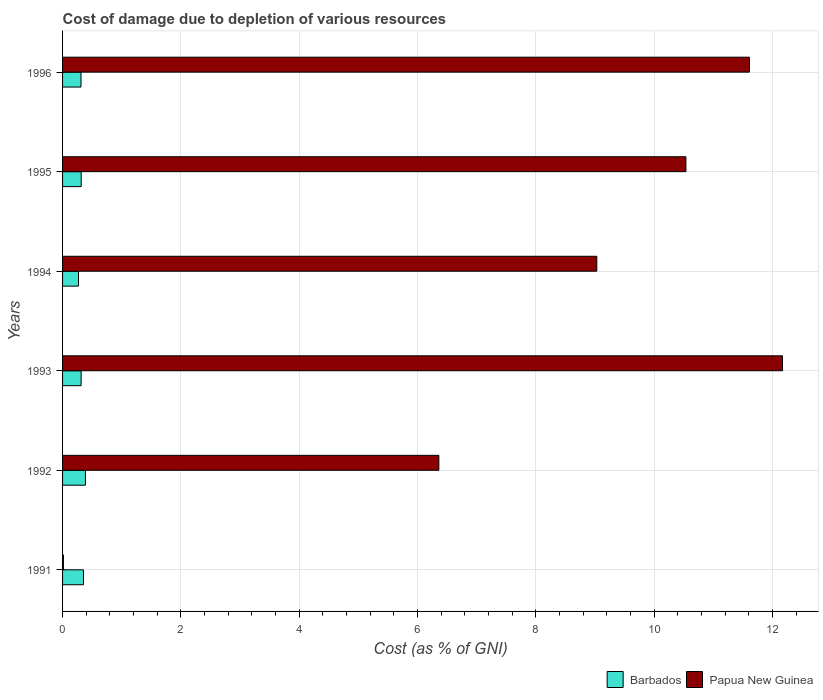How many different coloured bars are there?
Ensure brevity in your answer.  2. How many bars are there on the 3rd tick from the bottom?
Your response must be concise. 2. What is the label of the 1st group of bars from the top?
Provide a short and direct response. 1996. What is the cost of damage caused due to the depletion of various resources in Barbados in 1995?
Offer a very short reply. 0.32. Across all years, what is the maximum cost of damage caused due to the depletion of various resources in Papua New Guinea?
Ensure brevity in your answer.  12.17. Across all years, what is the minimum cost of damage caused due to the depletion of various resources in Barbados?
Your response must be concise. 0.27. In which year was the cost of damage caused due to the depletion of various resources in Papua New Guinea minimum?
Your response must be concise. 1991. What is the total cost of damage caused due to the depletion of various resources in Papua New Guinea in the graph?
Give a very brief answer. 49.71. What is the difference between the cost of damage caused due to the depletion of various resources in Barbados in 1993 and that in 1995?
Offer a very short reply. -0. What is the difference between the cost of damage caused due to the depletion of various resources in Barbados in 1994 and the cost of damage caused due to the depletion of various resources in Papua New Guinea in 1996?
Keep it short and to the point. -11.34. What is the average cost of damage caused due to the depletion of various resources in Barbados per year?
Offer a terse response. 0.32. In the year 1995, what is the difference between the cost of damage caused due to the depletion of various resources in Papua New Guinea and cost of damage caused due to the depletion of various resources in Barbados?
Offer a very short reply. 10.22. In how many years, is the cost of damage caused due to the depletion of various resources in Papua New Guinea greater than 0.4 %?
Your response must be concise. 5. What is the ratio of the cost of damage caused due to the depletion of various resources in Papua New Guinea in 1991 to that in 1994?
Your answer should be compact. 0. What is the difference between the highest and the second highest cost of damage caused due to the depletion of various resources in Barbados?
Your answer should be very brief. 0.03. What is the difference between the highest and the lowest cost of damage caused due to the depletion of various resources in Barbados?
Give a very brief answer. 0.12. What does the 1st bar from the top in 1996 represents?
Offer a terse response. Papua New Guinea. What does the 2nd bar from the bottom in 1995 represents?
Your answer should be very brief. Papua New Guinea. How many bars are there?
Offer a terse response. 12. How many years are there in the graph?
Your answer should be very brief. 6. Does the graph contain grids?
Give a very brief answer. Yes. What is the title of the graph?
Provide a short and direct response. Cost of damage due to depletion of various resources. Does "Peru" appear as one of the legend labels in the graph?
Provide a short and direct response. No. What is the label or title of the X-axis?
Your answer should be very brief. Cost (as % of GNI). What is the label or title of the Y-axis?
Keep it short and to the point. Years. What is the Cost (as % of GNI) in Barbados in 1991?
Offer a very short reply. 0.35. What is the Cost (as % of GNI) in Papua New Guinea in 1991?
Provide a short and direct response. 0.01. What is the Cost (as % of GNI) in Barbados in 1992?
Make the answer very short. 0.39. What is the Cost (as % of GNI) in Papua New Guinea in 1992?
Ensure brevity in your answer.  6.36. What is the Cost (as % of GNI) of Barbados in 1993?
Offer a very short reply. 0.31. What is the Cost (as % of GNI) of Papua New Guinea in 1993?
Your answer should be very brief. 12.17. What is the Cost (as % of GNI) in Barbados in 1994?
Make the answer very short. 0.27. What is the Cost (as % of GNI) of Papua New Guinea in 1994?
Your answer should be very brief. 9.03. What is the Cost (as % of GNI) in Barbados in 1995?
Ensure brevity in your answer.  0.32. What is the Cost (as % of GNI) in Papua New Guinea in 1995?
Give a very brief answer. 10.54. What is the Cost (as % of GNI) in Barbados in 1996?
Offer a terse response. 0.31. What is the Cost (as % of GNI) in Papua New Guinea in 1996?
Offer a very short reply. 11.61. Across all years, what is the maximum Cost (as % of GNI) of Barbados?
Make the answer very short. 0.39. Across all years, what is the maximum Cost (as % of GNI) of Papua New Guinea?
Your response must be concise. 12.17. Across all years, what is the minimum Cost (as % of GNI) of Barbados?
Keep it short and to the point. 0.27. Across all years, what is the minimum Cost (as % of GNI) of Papua New Guinea?
Provide a short and direct response. 0.01. What is the total Cost (as % of GNI) of Barbados in the graph?
Provide a succinct answer. 1.95. What is the total Cost (as % of GNI) in Papua New Guinea in the graph?
Keep it short and to the point. 49.71. What is the difference between the Cost (as % of GNI) in Barbados in 1991 and that in 1992?
Provide a succinct answer. -0.03. What is the difference between the Cost (as % of GNI) of Papua New Guinea in 1991 and that in 1992?
Offer a terse response. -6.34. What is the difference between the Cost (as % of GNI) of Barbados in 1991 and that in 1993?
Give a very brief answer. 0.04. What is the difference between the Cost (as % of GNI) in Papua New Guinea in 1991 and that in 1993?
Your answer should be compact. -12.15. What is the difference between the Cost (as % of GNI) of Barbados in 1991 and that in 1994?
Offer a very short reply. 0.08. What is the difference between the Cost (as % of GNI) of Papua New Guinea in 1991 and that in 1994?
Your answer should be compact. -9.01. What is the difference between the Cost (as % of GNI) of Barbados in 1991 and that in 1995?
Provide a succinct answer. 0.04. What is the difference between the Cost (as % of GNI) of Papua New Guinea in 1991 and that in 1995?
Make the answer very short. -10.52. What is the difference between the Cost (as % of GNI) in Barbados in 1991 and that in 1996?
Provide a short and direct response. 0.04. What is the difference between the Cost (as % of GNI) in Papua New Guinea in 1991 and that in 1996?
Offer a very short reply. -11.59. What is the difference between the Cost (as % of GNI) in Barbados in 1992 and that in 1993?
Make the answer very short. 0.07. What is the difference between the Cost (as % of GNI) of Papua New Guinea in 1992 and that in 1993?
Provide a short and direct response. -5.81. What is the difference between the Cost (as % of GNI) in Barbados in 1992 and that in 1994?
Make the answer very short. 0.12. What is the difference between the Cost (as % of GNI) of Papua New Guinea in 1992 and that in 1994?
Your response must be concise. -2.67. What is the difference between the Cost (as % of GNI) of Barbados in 1992 and that in 1995?
Provide a succinct answer. 0.07. What is the difference between the Cost (as % of GNI) of Papua New Guinea in 1992 and that in 1995?
Offer a very short reply. -4.18. What is the difference between the Cost (as % of GNI) in Barbados in 1992 and that in 1996?
Your response must be concise. 0.07. What is the difference between the Cost (as % of GNI) of Papua New Guinea in 1992 and that in 1996?
Your answer should be very brief. -5.25. What is the difference between the Cost (as % of GNI) of Barbados in 1993 and that in 1994?
Your answer should be very brief. 0.04. What is the difference between the Cost (as % of GNI) in Papua New Guinea in 1993 and that in 1994?
Provide a short and direct response. 3.14. What is the difference between the Cost (as % of GNI) of Barbados in 1993 and that in 1995?
Your answer should be very brief. -0. What is the difference between the Cost (as % of GNI) in Papua New Guinea in 1993 and that in 1995?
Your answer should be compact. 1.63. What is the difference between the Cost (as % of GNI) of Barbados in 1993 and that in 1996?
Your response must be concise. 0. What is the difference between the Cost (as % of GNI) of Papua New Guinea in 1993 and that in 1996?
Keep it short and to the point. 0.56. What is the difference between the Cost (as % of GNI) of Barbados in 1994 and that in 1995?
Your answer should be very brief. -0.05. What is the difference between the Cost (as % of GNI) of Papua New Guinea in 1994 and that in 1995?
Offer a terse response. -1.51. What is the difference between the Cost (as % of GNI) of Barbados in 1994 and that in 1996?
Make the answer very short. -0.04. What is the difference between the Cost (as % of GNI) in Papua New Guinea in 1994 and that in 1996?
Provide a succinct answer. -2.58. What is the difference between the Cost (as % of GNI) in Barbados in 1995 and that in 1996?
Offer a very short reply. 0. What is the difference between the Cost (as % of GNI) in Papua New Guinea in 1995 and that in 1996?
Your response must be concise. -1.07. What is the difference between the Cost (as % of GNI) of Barbados in 1991 and the Cost (as % of GNI) of Papua New Guinea in 1992?
Make the answer very short. -6.01. What is the difference between the Cost (as % of GNI) in Barbados in 1991 and the Cost (as % of GNI) in Papua New Guinea in 1993?
Provide a short and direct response. -11.81. What is the difference between the Cost (as % of GNI) in Barbados in 1991 and the Cost (as % of GNI) in Papua New Guinea in 1994?
Your answer should be compact. -8.68. What is the difference between the Cost (as % of GNI) in Barbados in 1991 and the Cost (as % of GNI) in Papua New Guinea in 1995?
Make the answer very short. -10.18. What is the difference between the Cost (as % of GNI) of Barbados in 1991 and the Cost (as % of GNI) of Papua New Guinea in 1996?
Keep it short and to the point. -11.26. What is the difference between the Cost (as % of GNI) in Barbados in 1992 and the Cost (as % of GNI) in Papua New Guinea in 1993?
Provide a succinct answer. -11.78. What is the difference between the Cost (as % of GNI) of Barbados in 1992 and the Cost (as % of GNI) of Papua New Guinea in 1994?
Give a very brief answer. -8.64. What is the difference between the Cost (as % of GNI) in Barbados in 1992 and the Cost (as % of GNI) in Papua New Guinea in 1995?
Give a very brief answer. -10.15. What is the difference between the Cost (as % of GNI) of Barbados in 1992 and the Cost (as % of GNI) of Papua New Guinea in 1996?
Your answer should be very brief. -11.22. What is the difference between the Cost (as % of GNI) of Barbados in 1993 and the Cost (as % of GNI) of Papua New Guinea in 1994?
Offer a very short reply. -8.72. What is the difference between the Cost (as % of GNI) in Barbados in 1993 and the Cost (as % of GNI) in Papua New Guinea in 1995?
Provide a short and direct response. -10.22. What is the difference between the Cost (as % of GNI) of Barbados in 1993 and the Cost (as % of GNI) of Papua New Guinea in 1996?
Provide a short and direct response. -11.29. What is the difference between the Cost (as % of GNI) in Barbados in 1994 and the Cost (as % of GNI) in Papua New Guinea in 1995?
Offer a terse response. -10.27. What is the difference between the Cost (as % of GNI) in Barbados in 1994 and the Cost (as % of GNI) in Papua New Guinea in 1996?
Your response must be concise. -11.34. What is the difference between the Cost (as % of GNI) of Barbados in 1995 and the Cost (as % of GNI) of Papua New Guinea in 1996?
Give a very brief answer. -11.29. What is the average Cost (as % of GNI) of Barbados per year?
Offer a terse response. 0.32. What is the average Cost (as % of GNI) of Papua New Guinea per year?
Your response must be concise. 8.29. In the year 1991, what is the difference between the Cost (as % of GNI) of Barbados and Cost (as % of GNI) of Papua New Guinea?
Offer a terse response. 0.34. In the year 1992, what is the difference between the Cost (as % of GNI) of Barbados and Cost (as % of GNI) of Papua New Guinea?
Provide a short and direct response. -5.97. In the year 1993, what is the difference between the Cost (as % of GNI) of Barbados and Cost (as % of GNI) of Papua New Guinea?
Make the answer very short. -11.85. In the year 1994, what is the difference between the Cost (as % of GNI) in Barbados and Cost (as % of GNI) in Papua New Guinea?
Provide a short and direct response. -8.76. In the year 1995, what is the difference between the Cost (as % of GNI) of Barbados and Cost (as % of GNI) of Papua New Guinea?
Your answer should be compact. -10.22. In the year 1996, what is the difference between the Cost (as % of GNI) of Barbados and Cost (as % of GNI) of Papua New Guinea?
Give a very brief answer. -11.3. What is the ratio of the Cost (as % of GNI) in Barbados in 1991 to that in 1992?
Your answer should be very brief. 0.91. What is the ratio of the Cost (as % of GNI) of Papua New Guinea in 1991 to that in 1992?
Ensure brevity in your answer.  0. What is the ratio of the Cost (as % of GNI) of Barbados in 1991 to that in 1993?
Your answer should be compact. 1.12. What is the ratio of the Cost (as % of GNI) in Papua New Guinea in 1991 to that in 1993?
Keep it short and to the point. 0. What is the ratio of the Cost (as % of GNI) of Barbados in 1991 to that in 1994?
Ensure brevity in your answer.  1.31. What is the ratio of the Cost (as % of GNI) of Papua New Guinea in 1991 to that in 1994?
Offer a terse response. 0. What is the ratio of the Cost (as % of GNI) in Barbados in 1991 to that in 1995?
Offer a very short reply. 1.12. What is the ratio of the Cost (as % of GNI) of Papua New Guinea in 1991 to that in 1995?
Provide a succinct answer. 0. What is the ratio of the Cost (as % of GNI) of Barbados in 1991 to that in 1996?
Offer a very short reply. 1.13. What is the ratio of the Cost (as % of GNI) in Papua New Guinea in 1991 to that in 1996?
Your response must be concise. 0. What is the ratio of the Cost (as % of GNI) in Barbados in 1992 to that in 1993?
Your answer should be compact. 1.23. What is the ratio of the Cost (as % of GNI) in Papua New Guinea in 1992 to that in 1993?
Your response must be concise. 0.52. What is the ratio of the Cost (as % of GNI) of Barbados in 1992 to that in 1994?
Offer a terse response. 1.43. What is the ratio of the Cost (as % of GNI) in Papua New Guinea in 1992 to that in 1994?
Provide a short and direct response. 0.7. What is the ratio of the Cost (as % of GNI) in Barbados in 1992 to that in 1995?
Provide a short and direct response. 1.23. What is the ratio of the Cost (as % of GNI) in Papua New Guinea in 1992 to that in 1995?
Keep it short and to the point. 0.6. What is the ratio of the Cost (as % of GNI) of Barbados in 1992 to that in 1996?
Provide a short and direct response. 1.24. What is the ratio of the Cost (as % of GNI) in Papua New Guinea in 1992 to that in 1996?
Provide a short and direct response. 0.55. What is the ratio of the Cost (as % of GNI) of Barbados in 1993 to that in 1994?
Offer a very short reply. 1.16. What is the ratio of the Cost (as % of GNI) in Papua New Guinea in 1993 to that in 1994?
Make the answer very short. 1.35. What is the ratio of the Cost (as % of GNI) of Papua New Guinea in 1993 to that in 1995?
Your response must be concise. 1.15. What is the ratio of the Cost (as % of GNI) of Barbados in 1993 to that in 1996?
Make the answer very short. 1.01. What is the ratio of the Cost (as % of GNI) of Papua New Guinea in 1993 to that in 1996?
Keep it short and to the point. 1.05. What is the ratio of the Cost (as % of GNI) of Barbados in 1994 to that in 1995?
Your response must be concise. 0.86. What is the ratio of the Cost (as % of GNI) of Papua New Guinea in 1994 to that in 1995?
Provide a short and direct response. 0.86. What is the ratio of the Cost (as % of GNI) in Barbados in 1994 to that in 1996?
Your response must be concise. 0.87. What is the ratio of the Cost (as % of GNI) of Papua New Guinea in 1994 to that in 1996?
Offer a very short reply. 0.78. What is the ratio of the Cost (as % of GNI) in Barbados in 1995 to that in 1996?
Keep it short and to the point. 1.01. What is the ratio of the Cost (as % of GNI) in Papua New Guinea in 1995 to that in 1996?
Your answer should be compact. 0.91. What is the difference between the highest and the second highest Cost (as % of GNI) of Barbados?
Make the answer very short. 0.03. What is the difference between the highest and the second highest Cost (as % of GNI) in Papua New Guinea?
Your answer should be very brief. 0.56. What is the difference between the highest and the lowest Cost (as % of GNI) in Barbados?
Ensure brevity in your answer.  0.12. What is the difference between the highest and the lowest Cost (as % of GNI) in Papua New Guinea?
Provide a succinct answer. 12.15. 